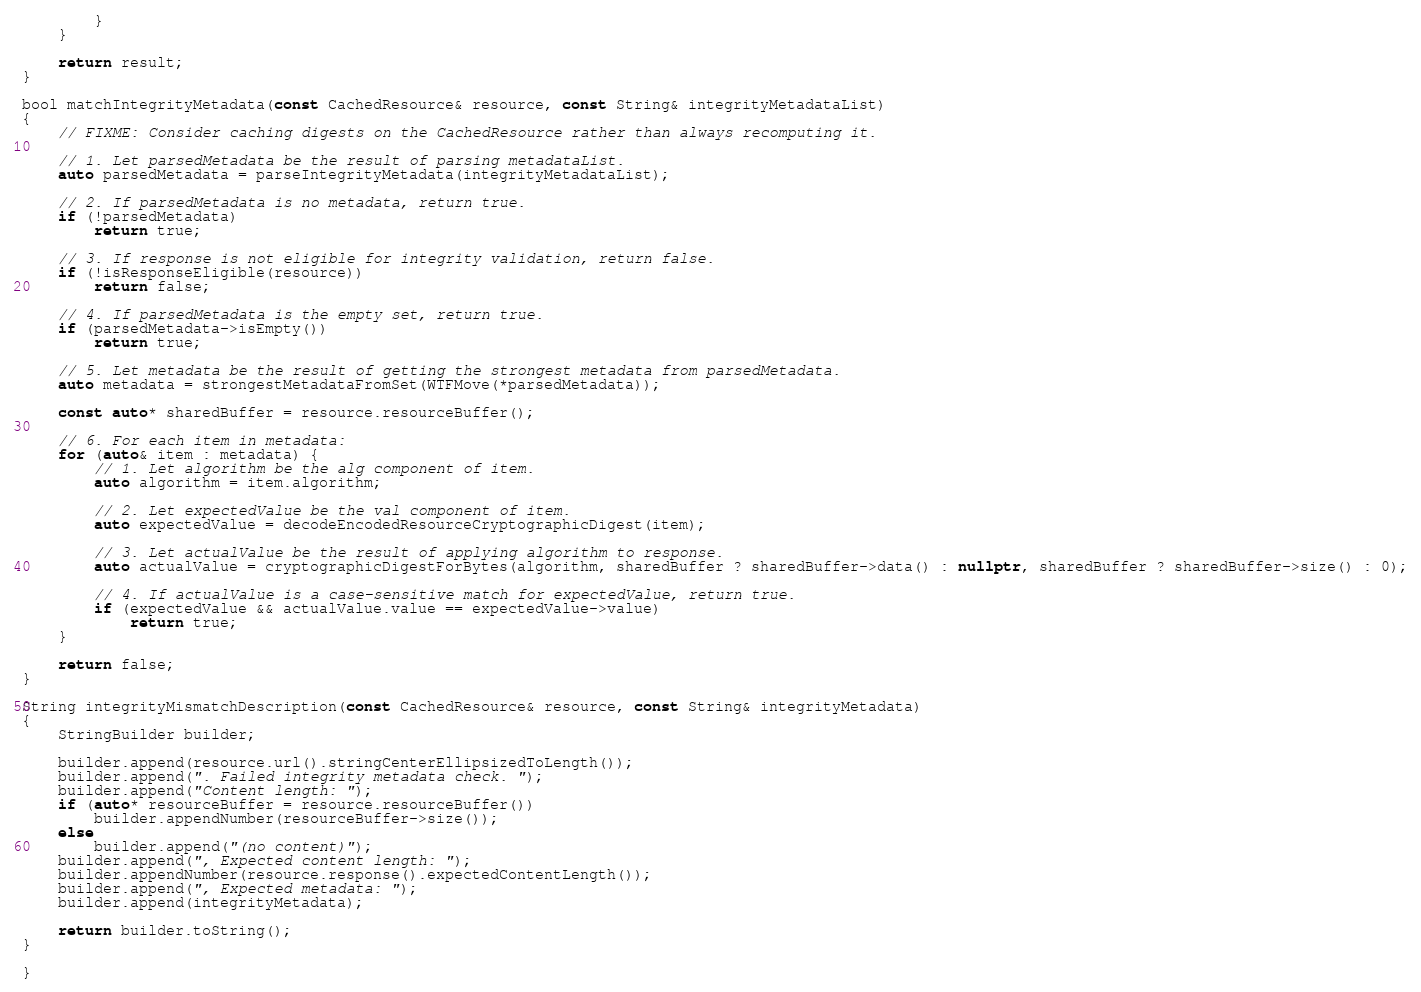<code> <loc_0><loc_0><loc_500><loc_500><_C++_>        }
    }

    return result;
}

bool matchIntegrityMetadata(const CachedResource& resource, const String& integrityMetadataList)
{
    // FIXME: Consider caching digests on the CachedResource rather than always recomputing it.

    // 1. Let parsedMetadata be the result of parsing metadataList.
    auto parsedMetadata = parseIntegrityMetadata(integrityMetadataList);
    
    // 2. If parsedMetadata is no metadata, return true.
    if (!parsedMetadata)
        return true;

    // 3. If response is not eligible for integrity validation, return false.
    if (!isResponseEligible(resource))
        return false;

    // 4. If parsedMetadata is the empty set, return true.
    if (parsedMetadata->isEmpty())
        return true;

    // 5. Let metadata be the result of getting the strongest metadata from parsedMetadata.
    auto metadata = strongestMetadataFromSet(WTFMove(*parsedMetadata));

    const auto* sharedBuffer = resource.resourceBuffer();
    
    // 6. For each item in metadata:
    for (auto& item : metadata) {
        // 1. Let algorithm be the alg component of item.
        auto algorithm = item.algorithm;
        
        // 2. Let expectedValue be the val component of item.
        auto expectedValue = decodeEncodedResourceCryptographicDigest(item);

        // 3. Let actualValue be the result of applying algorithm to response.
        auto actualValue = cryptographicDigestForBytes(algorithm, sharedBuffer ? sharedBuffer->data() : nullptr, sharedBuffer ? sharedBuffer->size() : 0);

        // 4. If actualValue is a case-sensitive match for expectedValue, return true.
        if (expectedValue && actualValue.value == expectedValue->value)
            return true;
    }
    
    return false;
}

String integrityMismatchDescription(const CachedResource& resource, const String& integrityMetadata)
{
    StringBuilder builder;

    builder.append(resource.url().stringCenterEllipsizedToLength());
    builder.append(". Failed integrity metadata check. ");
    builder.append("Content length: ");
    if (auto* resourceBuffer = resource.resourceBuffer())
        builder.appendNumber(resourceBuffer->size());
    else
        builder.append("(no content)");
    builder.append(", Expected content length: ");
    builder.appendNumber(resource.response().expectedContentLength());
    builder.append(", Expected metadata: ");
    builder.append(integrityMetadata);

    return builder.toString();
}

}
</code> 